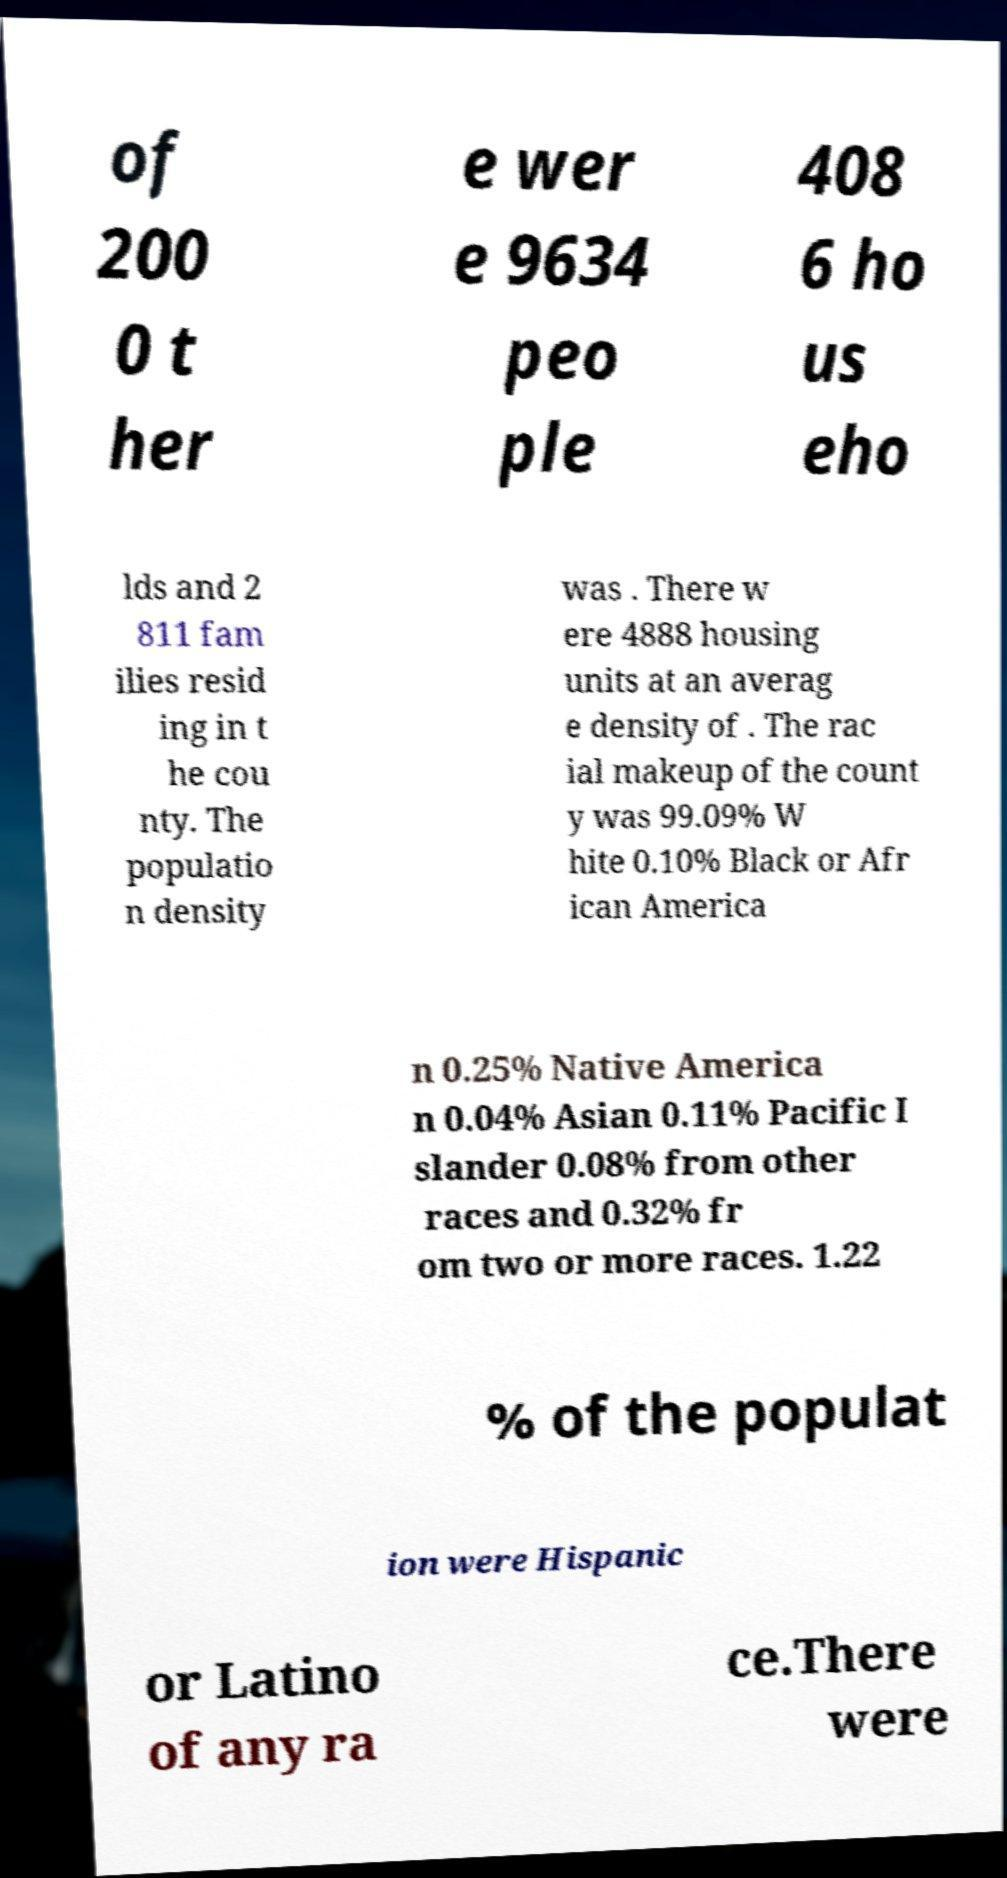Please identify and transcribe the text found in this image. of 200 0 t her e wer e 9634 peo ple 408 6 ho us eho lds and 2 811 fam ilies resid ing in t he cou nty. The populatio n density was . There w ere 4888 housing units at an averag e density of . The rac ial makeup of the count y was 99.09% W hite 0.10% Black or Afr ican America n 0.25% Native America n 0.04% Asian 0.11% Pacific I slander 0.08% from other races and 0.32% fr om two or more races. 1.22 % of the populat ion were Hispanic or Latino of any ra ce.There were 